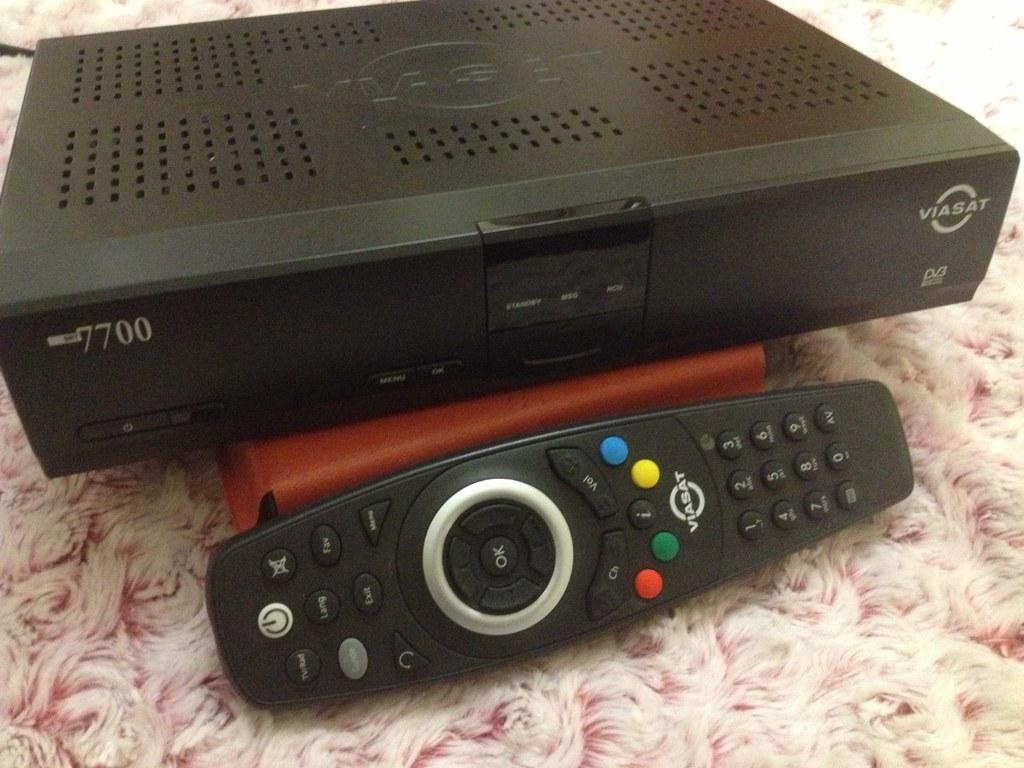<image>
Describe the image concisely. A black remote is by a Viasat cable box. 